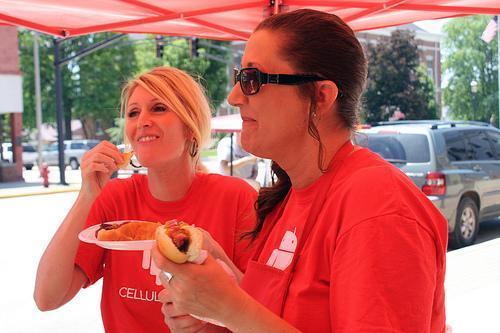How many of the men are eating?
Give a very brief answer. 0. 